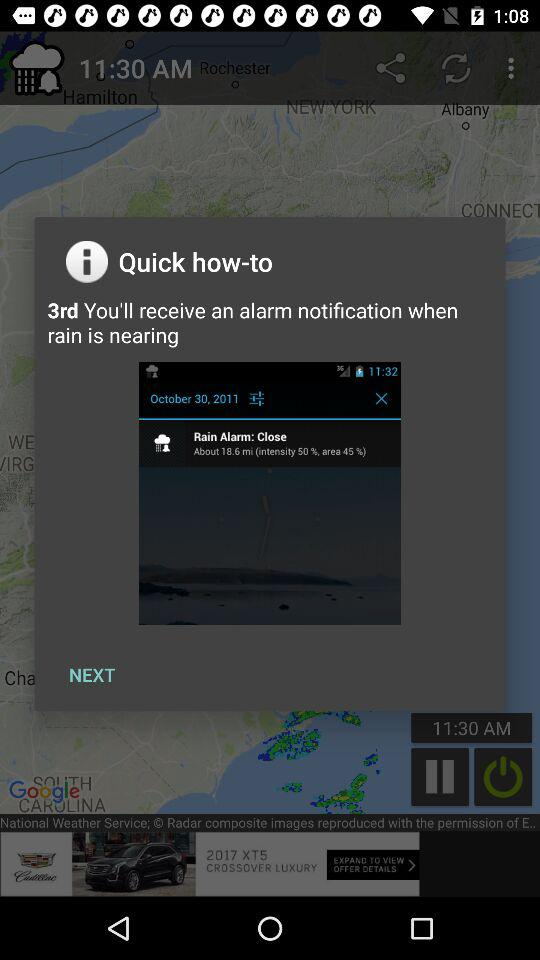What is the intensity of the rain? The intensity of the rain is 50%. 